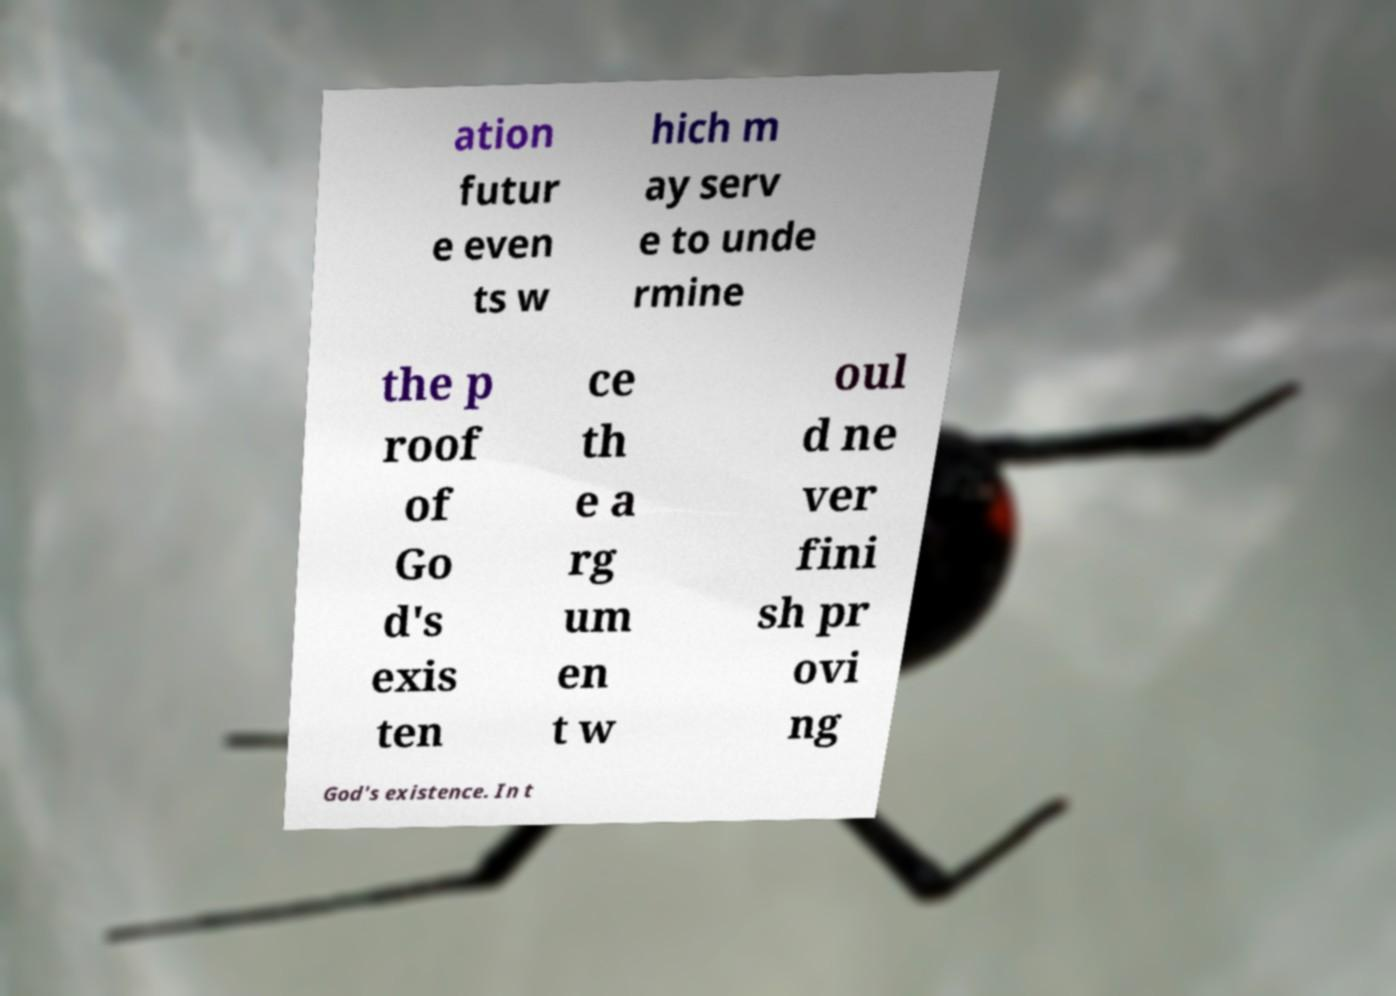Please read and relay the text visible in this image. What does it say? ation futur e even ts w hich m ay serv e to unde rmine the p roof of Go d's exis ten ce th e a rg um en t w oul d ne ver fini sh pr ovi ng God's existence. In t 